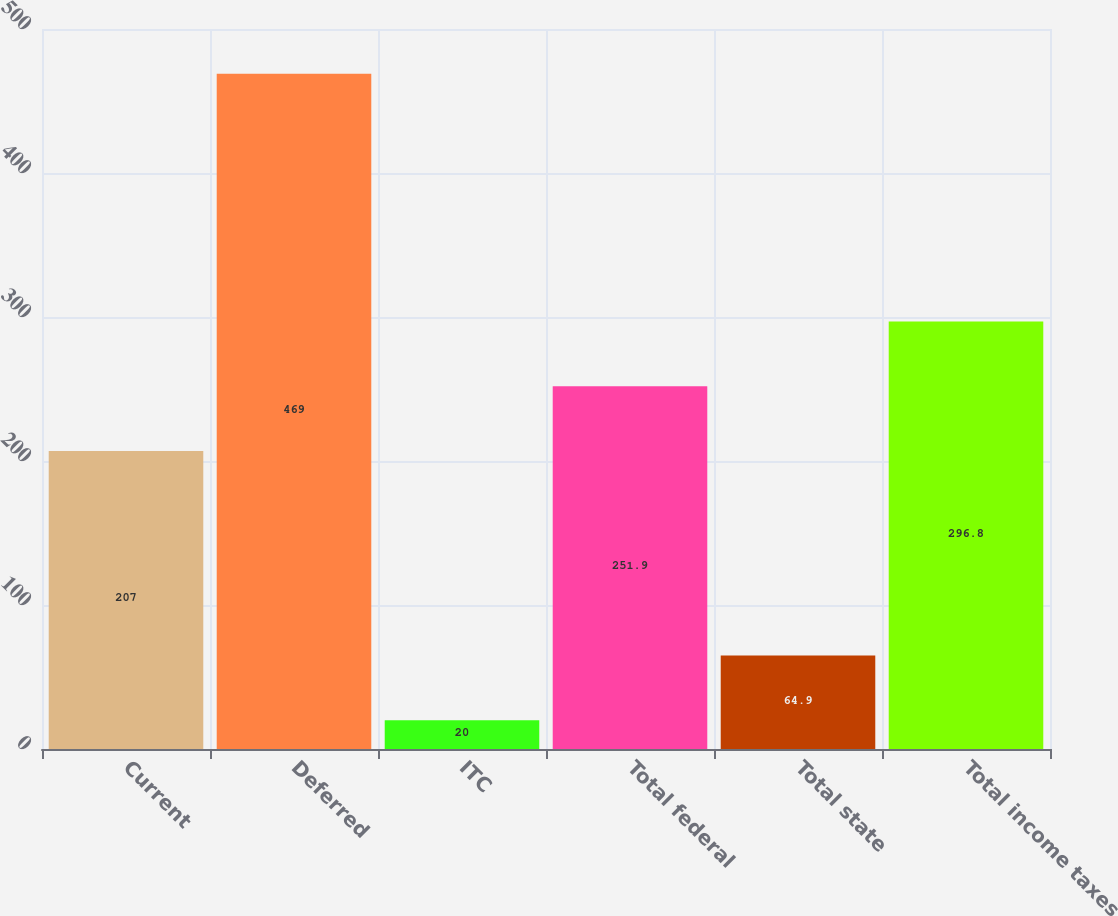<chart> <loc_0><loc_0><loc_500><loc_500><bar_chart><fcel>Current<fcel>Deferred<fcel>ITC<fcel>Total federal<fcel>Total state<fcel>Total income taxes<nl><fcel>207<fcel>469<fcel>20<fcel>251.9<fcel>64.9<fcel>296.8<nl></chart> 